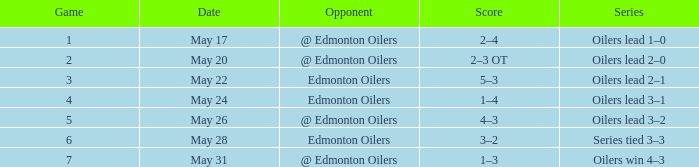What was the score when the edmonton oilers' opponent was playing a game smaller than 7 and the oilers were leading the series 3-2? 4–3. 